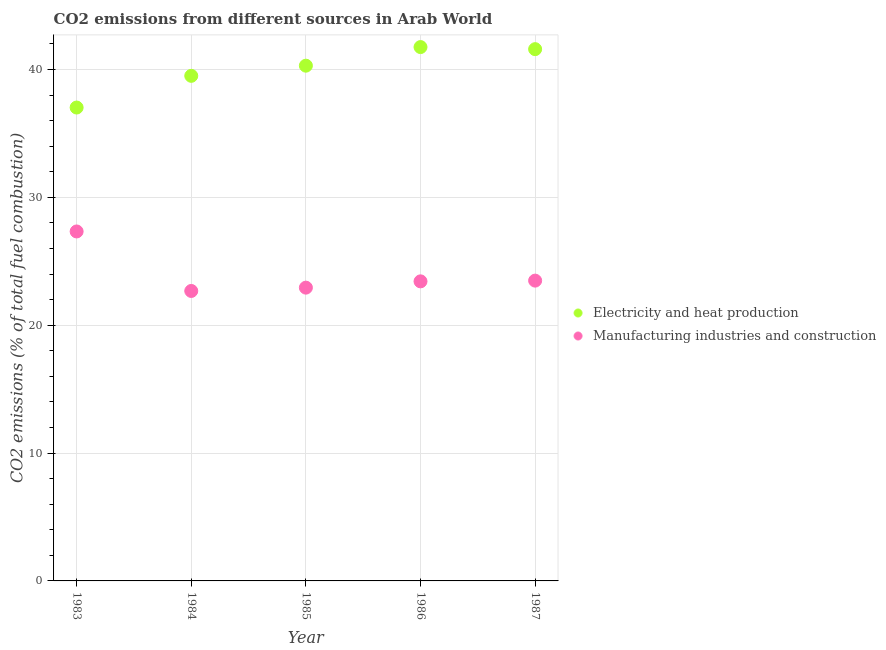How many different coloured dotlines are there?
Your response must be concise. 2. Is the number of dotlines equal to the number of legend labels?
Offer a terse response. Yes. What is the co2 emissions due to manufacturing industries in 1985?
Your answer should be very brief. 22.94. Across all years, what is the maximum co2 emissions due to electricity and heat production?
Ensure brevity in your answer.  41.75. Across all years, what is the minimum co2 emissions due to electricity and heat production?
Offer a very short reply. 37.03. In which year was the co2 emissions due to manufacturing industries minimum?
Your response must be concise. 1984. What is the total co2 emissions due to electricity and heat production in the graph?
Your response must be concise. 200.17. What is the difference between the co2 emissions due to electricity and heat production in 1984 and that in 1986?
Make the answer very short. -2.25. What is the difference between the co2 emissions due to manufacturing industries in 1985 and the co2 emissions due to electricity and heat production in 1987?
Make the answer very short. -18.65. What is the average co2 emissions due to manufacturing industries per year?
Provide a short and direct response. 23.97. In the year 1985, what is the difference between the co2 emissions due to manufacturing industries and co2 emissions due to electricity and heat production?
Your answer should be very brief. -17.36. What is the ratio of the co2 emissions due to manufacturing industries in 1983 to that in 1985?
Your response must be concise. 1.19. What is the difference between the highest and the second highest co2 emissions due to electricity and heat production?
Keep it short and to the point. 0.16. What is the difference between the highest and the lowest co2 emissions due to electricity and heat production?
Make the answer very short. 4.73. Is the sum of the co2 emissions due to manufacturing industries in 1983 and 1986 greater than the maximum co2 emissions due to electricity and heat production across all years?
Make the answer very short. Yes. How many years are there in the graph?
Your answer should be compact. 5. What is the difference between two consecutive major ticks on the Y-axis?
Provide a succinct answer. 10. Does the graph contain any zero values?
Offer a terse response. No. Does the graph contain grids?
Keep it short and to the point. Yes. How many legend labels are there?
Your answer should be compact. 2. What is the title of the graph?
Offer a terse response. CO2 emissions from different sources in Arab World. Does "Nitrous oxide emissions" appear as one of the legend labels in the graph?
Make the answer very short. No. What is the label or title of the Y-axis?
Provide a short and direct response. CO2 emissions (% of total fuel combustion). What is the CO2 emissions (% of total fuel combustion) in Electricity and heat production in 1983?
Your answer should be very brief. 37.03. What is the CO2 emissions (% of total fuel combustion) of Manufacturing industries and construction in 1983?
Keep it short and to the point. 27.33. What is the CO2 emissions (% of total fuel combustion) of Electricity and heat production in 1984?
Your answer should be compact. 39.5. What is the CO2 emissions (% of total fuel combustion) in Manufacturing industries and construction in 1984?
Offer a very short reply. 22.68. What is the CO2 emissions (% of total fuel combustion) in Electricity and heat production in 1985?
Offer a terse response. 40.3. What is the CO2 emissions (% of total fuel combustion) in Manufacturing industries and construction in 1985?
Offer a very short reply. 22.94. What is the CO2 emissions (% of total fuel combustion) in Electricity and heat production in 1986?
Keep it short and to the point. 41.75. What is the CO2 emissions (% of total fuel combustion) in Manufacturing industries and construction in 1986?
Your answer should be very brief. 23.43. What is the CO2 emissions (% of total fuel combustion) of Electricity and heat production in 1987?
Give a very brief answer. 41.59. What is the CO2 emissions (% of total fuel combustion) of Manufacturing industries and construction in 1987?
Ensure brevity in your answer.  23.49. Across all years, what is the maximum CO2 emissions (% of total fuel combustion) in Electricity and heat production?
Your answer should be compact. 41.75. Across all years, what is the maximum CO2 emissions (% of total fuel combustion) in Manufacturing industries and construction?
Offer a terse response. 27.33. Across all years, what is the minimum CO2 emissions (% of total fuel combustion) of Electricity and heat production?
Your answer should be compact. 37.03. Across all years, what is the minimum CO2 emissions (% of total fuel combustion) in Manufacturing industries and construction?
Keep it short and to the point. 22.68. What is the total CO2 emissions (% of total fuel combustion) of Electricity and heat production in the graph?
Provide a short and direct response. 200.17. What is the total CO2 emissions (% of total fuel combustion) of Manufacturing industries and construction in the graph?
Provide a short and direct response. 119.87. What is the difference between the CO2 emissions (% of total fuel combustion) of Electricity and heat production in 1983 and that in 1984?
Ensure brevity in your answer.  -2.48. What is the difference between the CO2 emissions (% of total fuel combustion) of Manufacturing industries and construction in 1983 and that in 1984?
Offer a very short reply. 4.65. What is the difference between the CO2 emissions (% of total fuel combustion) of Electricity and heat production in 1983 and that in 1985?
Keep it short and to the point. -3.27. What is the difference between the CO2 emissions (% of total fuel combustion) in Manufacturing industries and construction in 1983 and that in 1985?
Keep it short and to the point. 4.4. What is the difference between the CO2 emissions (% of total fuel combustion) of Electricity and heat production in 1983 and that in 1986?
Keep it short and to the point. -4.73. What is the difference between the CO2 emissions (% of total fuel combustion) of Manufacturing industries and construction in 1983 and that in 1986?
Make the answer very short. 3.9. What is the difference between the CO2 emissions (% of total fuel combustion) of Electricity and heat production in 1983 and that in 1987?
Ensure brevity in your answer.  -4.57. What is the difference between the CO2 emissions (% of total fuel combustion) of Manufacturing industries and construction in 1983 and that in 1987?
Offer a terse response. 3.85. What is the difference between the CO2 emissions (% of total fuel combustion) of Electricity and heat production in 1984 and that in 1985?
Offer a terse response. -0.79. What is the difference between the CO2 emissions (% of total fuel combustion) of Manufacturing industries and construction in 1984 and that in 1985?
Ensure brevity in your answer.  -0.26. What is the difference between the CO2 emissions (% of total fuel combustion) of Electricity and heat production in 1984 and that in 1986?
Offer a terse response. -2.25. What is the difference between the CO2 emissions (% of total fuel combustion) in Manufacturing industries and construction in 1984 and that in 1986?
Give a very brief answer. -0.75. What is the difference between the CO2 emissions (% of total fuel combustion) in Electricity and heat production in 1984 and that in 1987?
Provide a short and direct response. -2.09. What is the difference between the CO2 emissions (% of total fuel combustion) in Manufacturing industries and construction in 1984 and that in 1987?
Give a very brief answer. -0.81. What is the difference between the CO2 emissions (% of total fuel combustion) of Electricity and heat production in 1985 and that in 1986?
Your answer should be very brief. -1.46. What is the difference between the CO2 emissions (% of total fuel combustion) in Manufacturing industries and construction in 1985 and that in 1986?
Give a very brief answer. -0.49. What is the difference between the CO2 emissions (% of total fuel combustion) in Electricity and heat production in 1985 and that in 1987?
Offer a very short reply. -1.29. What is the difference between the CO2 emissions (% of total fuel combustion) of Manufacturing industries and construction in 1985 and that in 1987?
Ensure brevity in your answer.  -0.55. What is the difference between the CO2 emissions (% of total fuel combustion) of Electricity and heat production in 1986 and that in 1987?
Give a very brief answer. 0.16. What is the difference between the CO2 emissions (% of total fuel combustion) in Manufacturing industries and construction in 1986 and that in 1987?
Your response must be concise. -0.06. What is the difference between the CO2 emissions (% of total fuel combustion) in Electricity and heat production in 1983 and the CO2 emissions (% of total fuel combustion) in Manufacturing industries and construction in 1984?
Offer a very short reply. 14.35. What is the difference between the CO2 emissions (% of total fuel combustion) in Electricity and heat production in 1983 and the CO2 emissions (% of total fuel combustion) in Manufacturing industries and construction in 1985?
Your response must be concise. 14.09. What is the difference between the CO2 emissions (% of total fuel combustion) of Electricity and heat production in 1983 and the CO2 emissions (% of total fuel combustion) of Manufacturing industries and construction in 1986?
Offer a terse response. 13.59. What is the difference between the CO2 emissions (% of total fuel combustion) in Electricity and heat production in 1983 and the CO2 emissions (% of total fuel combustion) in Manufacturing industries and construction in 1987?
Your answer should be very brief. 13.54. What is the difference between the CO2 emissions (% of total fuel combustion) of Electricity and heat production in 1984 and the CO2 emissions (% of total fuel combustion) of Manufacturing industries and construction in 1985?
Your answer should be very brief. 16.57. What is the difference between the CO2 emissions (% of total fuel combustion) of Electricity and heat production in 1984 and the CO2 emissions (% of total fuel combustion) of Manufacturing industries and construction in 1986?
Your answer should be compact. 16.07. What is the difference between the CO2 emissions (% of total fuel combustion) in Electricity and heat production in 1984 and the CO2 emissions (% of total fuel combustion) in Manufacturing industries and construction in 1987?
Your response must be concise. 16.02. What is the difference between the CO2 emissions (% of total fuel combustion) in Electricity and heat production in 1985 and the CO2 emissions (% of total fuel combustion) in Manufacturing industries and construction in 1986?
Provide a short and direct response. 16.87. What is the difference between the CO2 emissions (% of total fuel combustion) of Electricity and heat production in 1985 and the CO2 emissions (% of total fuel combustion) of Manufacturing industries and construction in 1987?
Your answer should be very brief. 16.81. What is the difference between the CO2 emissions (% of total fuel combustion) of Electricity and heat production in 1986 and the CO2 emissions (% of total fuel combustion) of Manufacturing industries and construction in 1987?
Provide a short and direct response. 18.27. What is the average CO2 emissions (% of total fuel combustion) in Electricity and heat production per year?
Provide a short and direct response. 40.03. What is the average CO2 emissions (% of total fuel combustion) of Manufacturing industries and construction per year?
Ensure brevity in your answer.  23.97. In the year 1983, what is the difference between the CO2 emissions (% of total fuel combustion) of Electricity and heat production and CO2 emissions (% of total fuel combustion) of Manufacturing industries and construction?
Offer a very short reply. 9.69. In the year 1984, what is the difference between the CO2 emissions (% of total fuel combustion) of Electricity and heat production and CO2 emissions (% of total fuel combustion) of Manufacturing industries and construction?
Offer a very short reply. 16.83. In the year 1985, what is the difference between the CO2 emissions (% of total fuel combustion) in Electricity and heat production and CO2 emissions (% of total fuel combustion) in Manufacturing industries and construction?
Offer a terse response. 17.36. In the year 1986, what is the difference between the CO2 emissions (% of total fuel combustion) of Electricity and heat production and CO2 emissions (% of total fuel combustion) of Manufacturing industries and construction?
Your answer should be very brief. 18.32. In the year 1987, what is the difference between the CO2 emissions (% of total fuel combustion) of Electricity and heat production and CO2 emissions (% of total fuel combustion) of Manufacturing industries and construction?
Provide a succinct answer. 18.1. What is the ratio of the CO2 emissions (% of total fuel combustion) in Electricity and heat production in 1983 to that in 1984?
Your answer should be compact. 0.94. What is the ratio of the CO2 emissions (% of total fuel combustion) in Manufacturing industries and construction in 1983 to that in 1984?
Provide a short and direct response. 1.21. What is the ratio of the CO2 emissions (% of total fuel combustion) of Electricity and heat production in 1983 to that in 1985?
Your answer should be compact. 0.92. What is the ratio of the CO2 emissions (% of total fuel combustion) of Manufacturing industries and construction in 1983 to that in 1985?
Offer a terse response. 1.19. What is the ratio of the CO2 emissions (% of total fuel combustion) in Electricity and heat production in 1983 to that in 1986?
Your answer should be compact. 0.89. What is the ratio of the CO2 emissions (% of total fuel combustion) of Manufacturing industries and construction in 1983 to that in 1986?
Provide a short and direct response. 1.17. What is the ratio of the CO2 emissions (% of total fuel combustion) in Electricity and heat production in 1983 to that in 1987?
Offer a terse response. 0.89. What is the ratio of the CO2 emissions (% of total fuel combustion) of Manufacturing industries and construction in 1983 to that in 1987?
Make the answer very short. 1.16. What is the ratio of the CO2 emissions (% of total fuel combustion) in Electricity and heat production in 1984 to that in 1985?
Your answer should be compact. 0.98. What is the ratio of the CO2 emissions (% of total fuel combustion) of Manufacturing industries and construction in 1984 to that in 1985?
Give a very brief answer. 0.99. What is the ratio of the CO2 emissions (% of total fuel combustion) of Electricity and heat production in 1984 to that in 1986?
Your answer should be compact. 0.95. What is the ratio of the CO2 emissions (% of total fuel combustion) in Manufacturing industries and construction in 1984 to that in 1986?
Your response must be concise. 0.97. What is the ratio of the CO2 emissions (% of total fuel combustion) in Electricity and heat production in 1984 to that in 1987?
Offer a very short reply. 0.95. What is the ratio of the CO2 emissions (% of total fuel combustion) in Manufacturing industries and construction in 1984 to that in 1987?
Ensure brevity in your answer.  0.97. What is the ratio of the CO2 emissions (% of total fuel combustion) in Electricity and heat production in 1985 to that in 1986?
Offer a terse response. 0.97. What is the ratio of the CO2 emissions (% of total fuel combustion) in Electricity and heat production in 1985 to that in 1987?
Keep it short and to the point. 0.97. What is the ratio of the CO2 emissions (% of total fuel combustion) in Manufacturing industries and construction in 1985 to that in 1987?
Your response must be concise. 0.98. What is the ratio of the CO2 emissions (% of total fuel combustion) in Electricity and heat production in 1986 to that in 1987?
Your answer should be compact. 1. What is the difference between the highest and the second highest CO2 emissions (% of total fuel combustion) of Electricity and heat production?
Give a very brief answer. 0.16. What is the difference between the highest and the second highest CO2 emissions (% of total fuel combustion) of Manufacturing industries and construction?
Provide a short and direct response. 3.85. What is the difference between the highest and the lowest CO2 emissions (% of total fuel combustion) in Electricity and heat production?
Offer a very short reply. 4.73. What is the difference between the highest and the lowest CO2 emissions (% of total fuel combustion) in Manufacturing industries and construction?
Offer a very short reply. 4.65. 